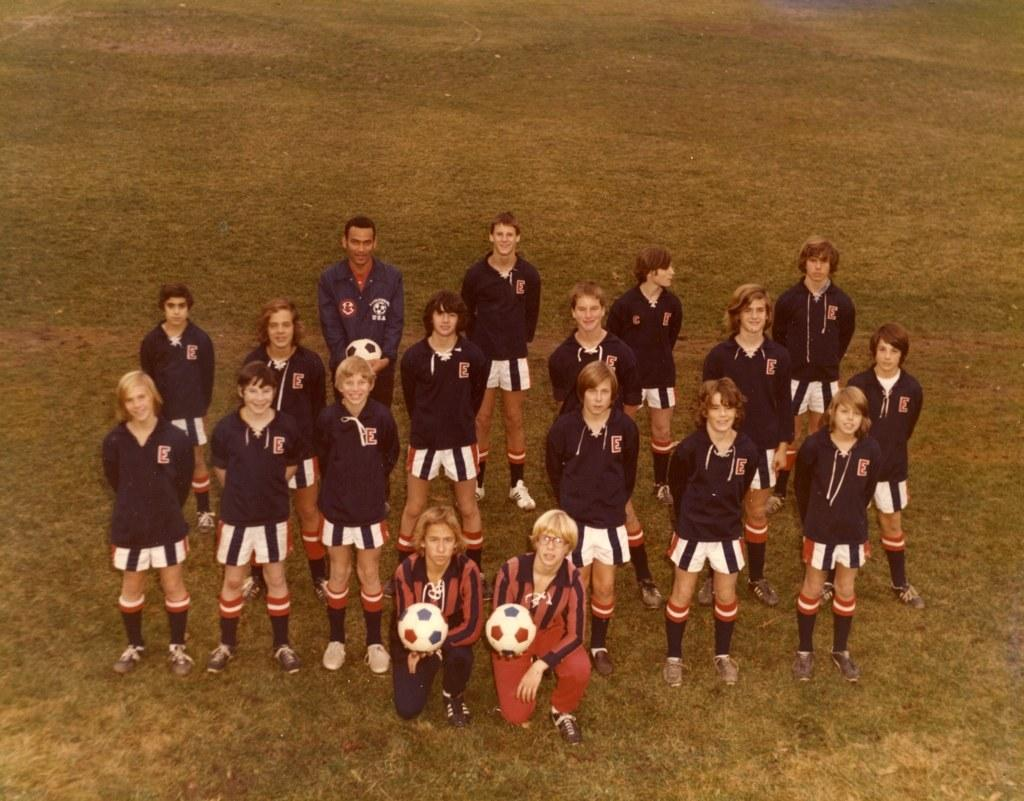How many people are in the image? There are people in the image, but the exact number is not specified. What are some people doing in the image? Some people are standing, and some are wearing sports dress. What objects are being held by some people in the image? Some people are holding balls in their hands. What type of surface is visible on the ground in the image? There is grass on the ground in the image. What type of letters are being written with ink in the image? There are no letters or ink present in the image; it features people standing and holding balls on a grassy surface. 